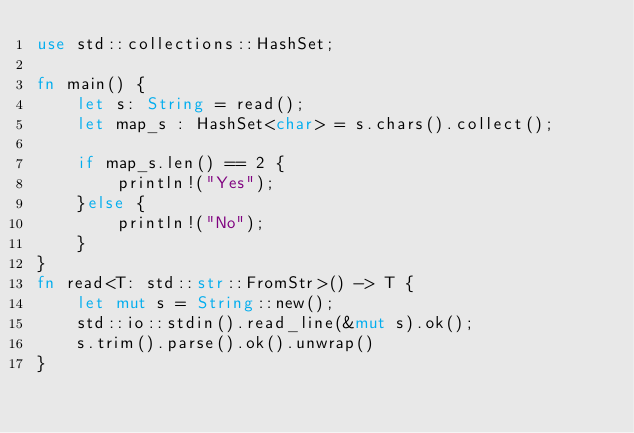<code> <loc_0><loc_0><loc_500><loc_500><_Rust_>use std::collections::HashSet;

fn main() {
    let s: String = read();
    let map_s : HashSet<char> = s.chars().collect();

    if map_s.len() == 2 {
        println!("Yes");
    }else {
        println!("No");
    }
}
fn read<T: std::str::FromStr>() -> T {
    let mut s = String::new();
    std::io::stdin().read_line(&mut s).ok();
    s.trim().parse().ok().unwrap()
}
</code> 